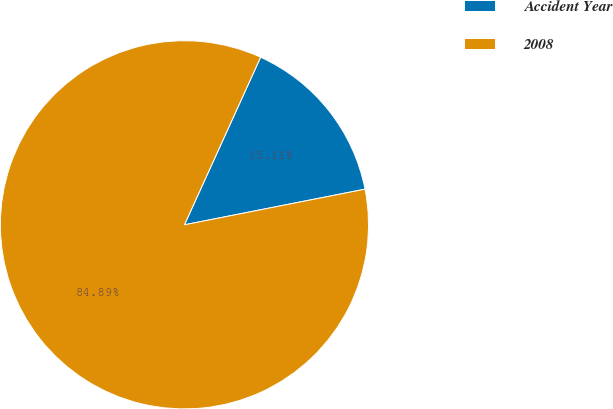<chart> <loc_0><loc_0><loc_500><loc_500><pie_chart><fcel>Accident Year<fcel>2008<nl><fcel>15.11%<fcel>84.89%<nl></chart> 